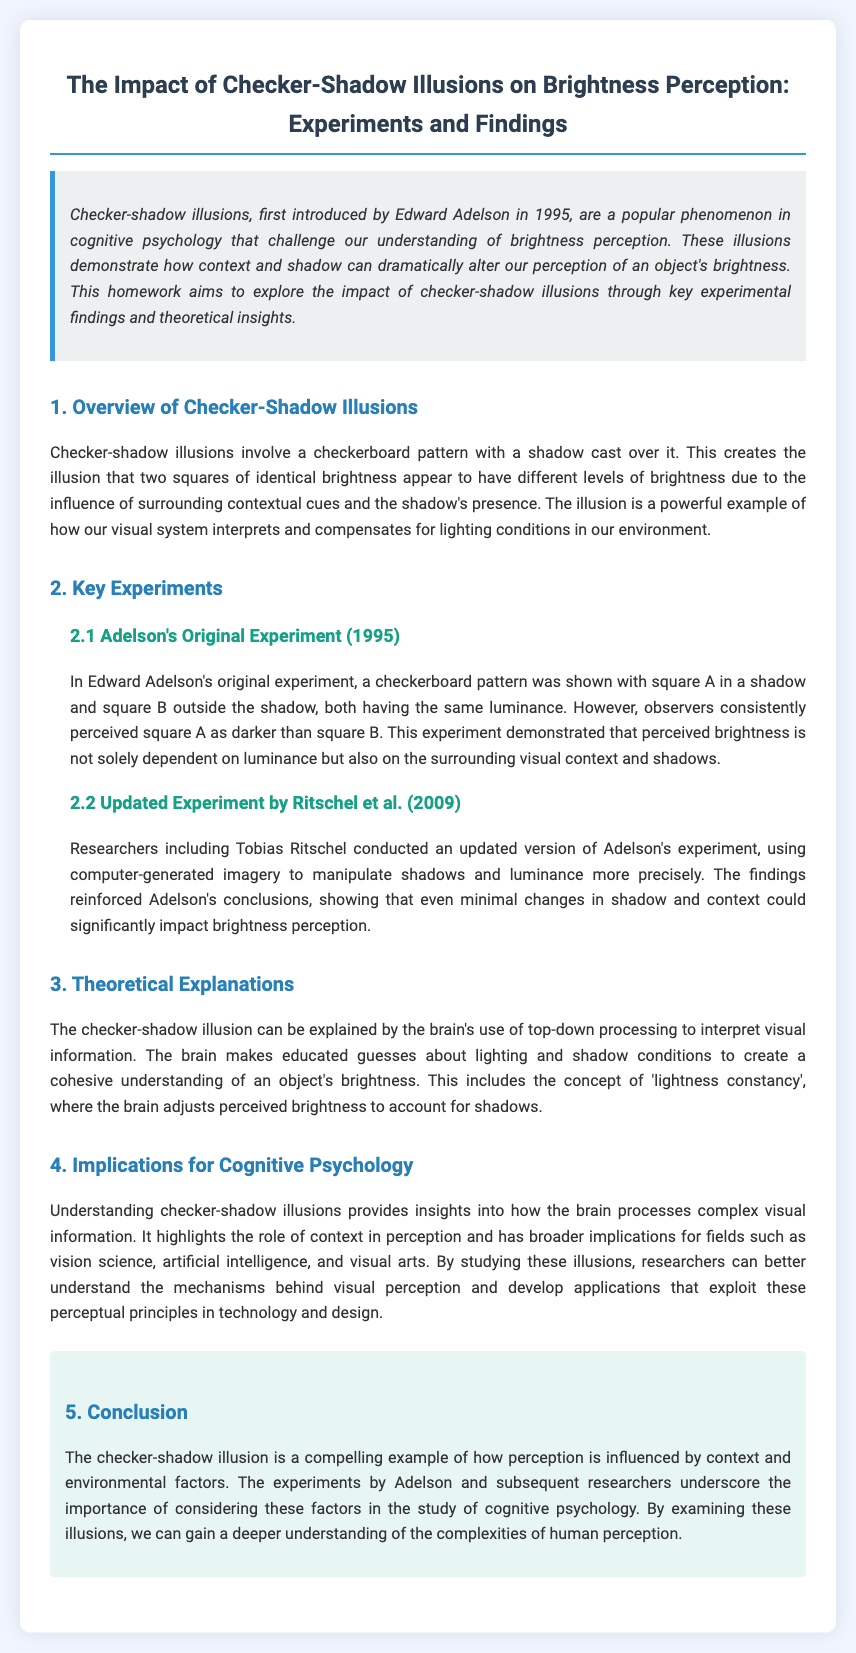What year was the checker-shadow illusion first introduced? The document states that the checker-shadow illusion was first introduced by Edward Adelson in 1995.
Answer: 1995 What is the name of the researcher who conducted the original experiment? The document mentions that the original experiment was conducted by Edward Adelson.
Answer: Edward Adelson In the updated experiment by Ritschel et al., what type of imagery was used? The document specifies that computer-generated imagery was used in Ritschel et al.'s updated experiment.
Answer: computer-generated imagery What is the primary focus of cognitive psychology as discussed in the document? The document states that the primary focus is on how the brain processes complex visual information.
Answer: visual information What psychological principle is highlighted in the theoretical explanations section? The document refers to 'lightness constancy' as a key psychological principle in the theoretical explanations.
Answer: lightness constancy How does the checker-shadow illusion affect the perception of square A and B? The document explains that square A is perceived as darker than square B due to shadows and context.
Answer: darker What is one implication of understanding checker-shadow illusions mentioned in the document? The document points out implications for fields such as vision science, artificial intelligence, and visual arts.
Answer: vision science Who conducted the updated experiment referenced in the document? The document mentions researchers including Tobias Ritschel conducted the updated experiment.
Answer: Tobias Ritschel What is the conclusion regarding the checker-shadow illusion's influence on perception? The document concludes that the illusion demonstrates the influence of context and environmental factors on perception.
Answer: context and environmental factors 